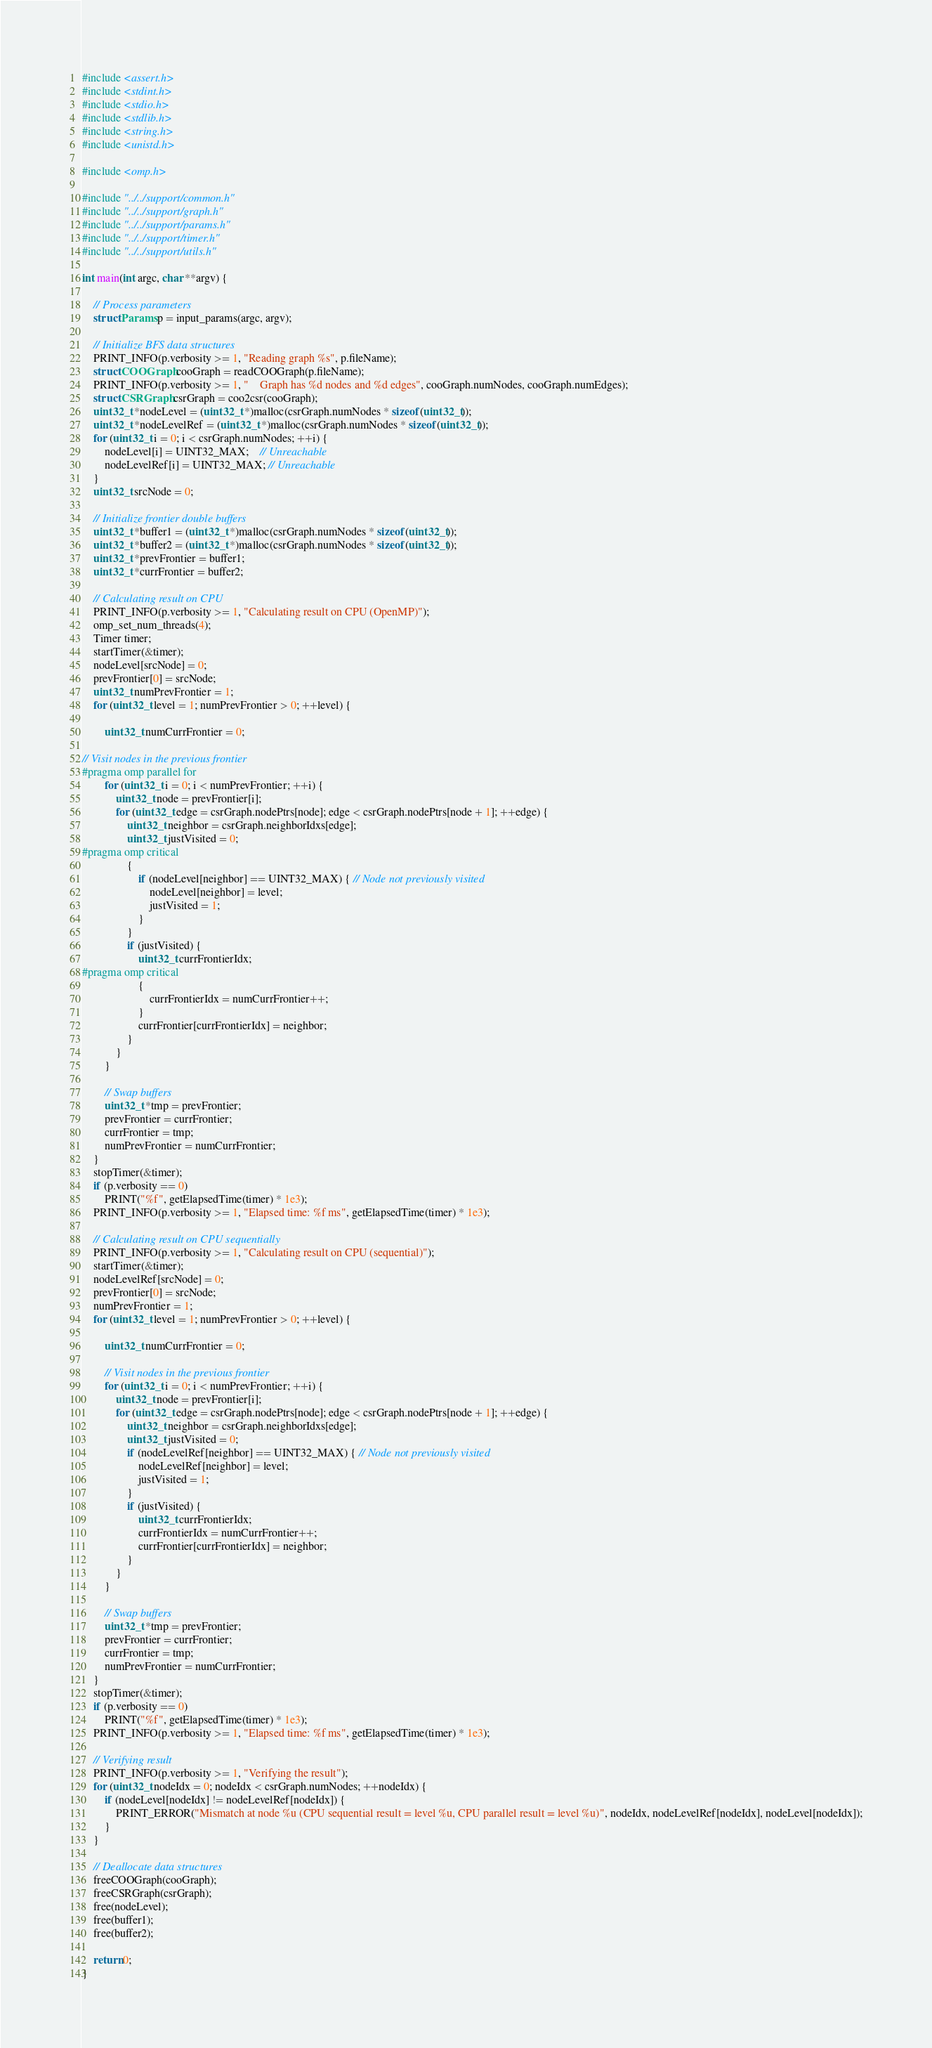Convert code to text. <code><loc_0><loc_0><loc_500><loc_500><_C_>#include <assert.h>
#include <stdint.h>
#include <stdio.h>
#include <stdlib.h>
#include <string.h>
#include <unistd.h>

#include <omp.h>

#include "../../support/common.h"
#include "../../support/graph.h"
#include "../../support/params.h"
#include "../../support/timer.h"
#include "../../support/utils.h"

int main(int argc, char **argv) {

    // Process parameters
    struct Params p = input_params(argc, argv);

    // Initialize BFS data structures
    PRINT_INFO(p.verbosity >= 1, "Reading graph %s", p.fileName);
    struct COOGraph cooGraph = readCOOGraph(p.fileName);
    PRINT_INFO(p.verbosity >= 1, "    Graph has %d nodes and %d edges", cooGraph.numNodes, cooGraph.numEdges);
    struct CSRGraph csrGraph = coo2csr(cooGraph);
    uint32_t *nodeLevel = (uint32_t *)malloc(csrGraph.numNodes * sizeof(uint32_t));
    uint32_t *nodeLevelRef = (uint32_t *)malloc(csrGraph.numNodes * sizeof(uint32_t));
    for (uint32_t i = 0; i < csrGraph.numNodes; ++i) {
        nodeLevel[i] = UINT32_MAX;    // Unreachable
        nodeLevelRef[i] = UINT32_MAX; // Unreachable
    }
    uint32_t srcNode = 0;

    // Initialize frontier double buffers
    uint32_t *buffer1 = (uint32_t *)malloc(csrGraph.numNodes * sizeof(uint32_t));
    uint32_t *buffer2 = (uint32_t *)malloc(csrGraph.numNodes * sizeof(uint32_t));
    uint32_t *prevFrontier = buffer1;
    uint32_t *currFrontier = buffer2;

    // Calculating result on CPU
    PRINT_INFO(p.verbosity >= 1, "Calculating result on CPU (OpenMP)");
    omp_set_num_threads(4);
    Timer timer;
    startTimer(&timer);
    nodeLevel[srcNode] = 0;
    prevFrontier[0] = srcNode;
    uint32_t numPrevFrontier = 1;
    for (uint32_t level = 1; numPrevFrontier > 0; ++level) {

        uint32_t numCurrFrontier = 0;

// Visit nodes in the previous frontier
#pragma omp parallel for
        for (uint32_t i = 0; i < numPrevFrontier; ++i) {
            uint32_t node = prevFrontier[i];
            for (uint32_t edge = csrGraph.nodePtrs[node]; edge < csrGraph.nodePtrs[node + 1]; ++edge) {
                uint32_t neighbor = csrGraph.neighborIdxs[edge];
                uint32_t justVisited = 0;
#pragma omp critical
                {
                    if (nodeLevel[neighbor] == UINT32_MAX) { // Node not previously visited
                        nodeLevel[neighbor] = level;
                        justVisited = 1;
                    }
                }
                if (justVisited) {
                    uint32_t currFrontierIdx;
#pragma omp critical
                    {
                        currFrontierIdx = numCurrFrontier++;
                    }
                    currFrontier[currFrontierIdx] = neighbor;
                }
            }
        }

        // Swap buffers
        uint32_t *tmp = prevFrontier;
        prevFrontier = currFrontier;
        currFrontier = tmp;
        numPrevFrontier = numCurrFrontier;
    }
    stopTimer(&timer);
    if (p.verbosity == 0)
        PRINT("%f", getElapsedTime(timer) * 1e3);
    PRINT_INFO(p.verbosity >= 1, "Elapsed time: %f ms", getElapsedTime(timer) * 1e3);

    // Calculating result on CPU sequentially
    PRINT_INFO(p.verbosity >= 1, "Calculating result on CPU (sequential)");
    startTimer(&timer);
    nodeLevelRef[srcNode] = 0;
    prevFrontier[0] = srcNode;
    numPrevFrontier = 1;
    for (uint32_t level = 1; numPrevFrontier > 0; ++level) {

        uint32_t numCurrFrontier = 0;

        // Visit nodes in the previous frontier
        for (uint32_t i = 0; i < numPrevFrontier; ++i) {
            uint32_t node = prevFrontier[i];
            for (uint32_t edge = csrGraph.nodePtrs[node]; edge < csrGraph.nodePtrs[node + 1]; ++edge) {
                uint32_t neighbor = csrGraph.neighborIdxs[edge];
                uint32_t justVisited = 0;
                if (nodeLevelRef[neighbor] == UINT32_MAX) { // Node not previously visited
                    nodeLevelRef[neighbor] = level;
                    justVisited = 1;
                }
                if (justVisited) {
                    uint32_t currFrontierIdx;
                    currFrontierIdx = numCurrFrontier++;
                    currFrontier[currFrontierIdx] = neighbor;
                }
            }
        }

        // Swap buffers
        uint32_t *tmp = prevFrontier;
        prevFrontier = currFrontier;
        currFrontier = tmp;
        numPrevFrontier = numCurrFrontier;
    }
    stopTimer(&timer);
    if (p.verbosity == 0)
        PRINT("%f", getElapsedTime(timer) * 1e3);
    PRINT_INFO(p.verbosity >= 1, "Elapsed time: %f ms", getElapsedTime(timer) * 1e3);

    // Verifying result
    PRINT_INFO(p.verbosity >= 1, "Verifying the result");
    for (uint32_t nodeIdx = 0; nodeIdx < csrGraph.numNodes; ++nodeIdx) {
        if (nodeLevel[nodeIdx] != nodeLevelRef[nodeIdx]) {
            PRINT_ERROR("Mismatch at node %u (CPU sequential result = level %u, CPU parallel result = level %u)", nodeIdx, nodeLevelRef[nodeIdx], nodeLevel[nodeIdx]);
        }
    }

    // Deallocate data structures
    freeCOOGraph(cooGraph);
    freeCSRGraph(csrGraph);
    free(nodeLevel);
    free(buffer1);
    free(buffer2);

    return 0;
}
</code> 